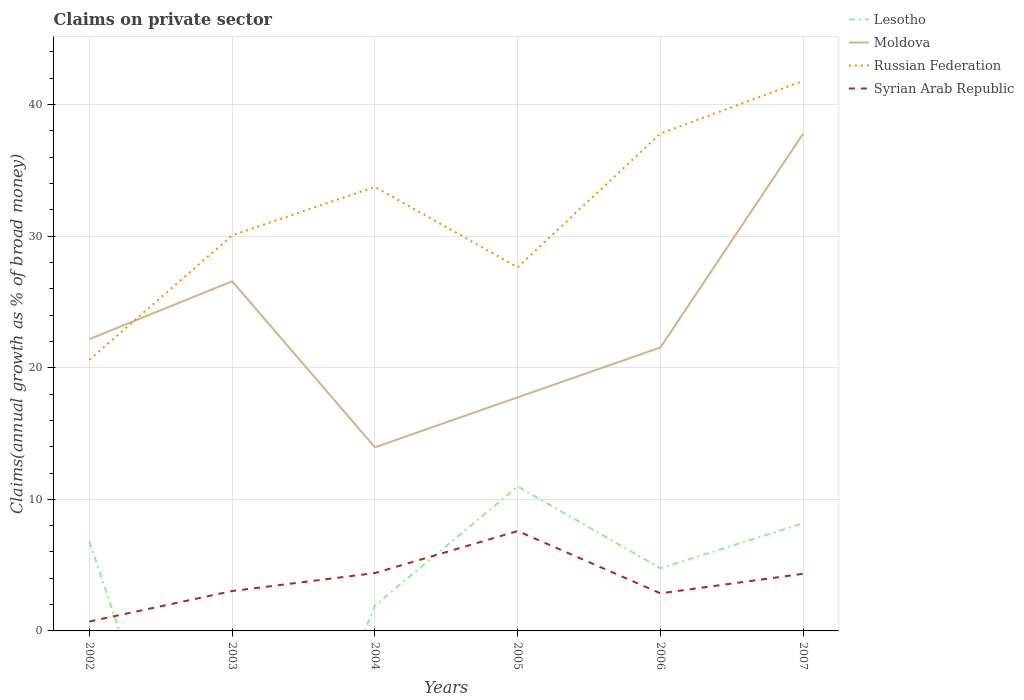How many different coloured lines are there?
Offer a terse response. 4. Across all years, what is the maximum percentage of broad money claimed on private sector in Moldova?
Make the answer very short. 13.96. What is the total percentage of broad money claimed on private sector in Russian Federation in the graph?
Offer a very short reply. -4. What is the difference between the highest and the second highest percentage of broad money claimed on private sector in Lesotho?
Your answer should be very brief. 10.98. Is the percentage of broad money claimed on private sector in Syrian Arab Republic strictly greater than the percentage of broad money claimed on private sector in Moldova over the years?
Your answer should be compact. Yes. How many lines are there?
Give a very brief answer. 4. How many years are there in the graph?
Your answer should be very brief. 6. What is the difference between two consecutive major ticks on the Y-axis?
Offer a terse response. 10. Are the values on the major ticks of Y-axis written in scientific E-notation?
Make the answer very short. No. Does the graph contain any zero values?
Make the answer very short. Yes. Does the graph contain grids?
Provide a short and direct response. Yes. Where does the legend appear in the graph?
Offer a very short reply. Top right. How many legend labels are there?
Your answer should be compact. 4. What is the title of the graph?
Keep it short and to the point. Claims on private sector. Does "Guam" appear as one of the legend labels in the graph?
Give a very brief answer. No. What is the label or title of the Y-axis?
Offer a terse response. Claims(annual growth as % of broad money). What is the Claims(annual growth as % of broad money) of Lesotho in 2002?
Your response must be concise. 6.79. What is the Claims(annual growth as % of broad money) of Moldova in 2002?
Give a very brief answer. 22.18. What is the Claims(annual growth as % of broad money) in Russian Federation in 2002?
Provide a short and direct response. 20.61. What is the Claims(annual growth as % of broad money) in Syrian Arab Republic in 2002?
Offer a very short reply. 0.72. What is the Claims(annual growth as % of broad money) of Moldova in 2003?
Your answer should be compact. 26.57. What is the Claims(annual growth as % of broad money) in Russian Federation in 2003?
Your answer should be very brief. 30.06. What is the Claims(annual growth as % of broad money) of Syrian Arab Republic in 2003?
Offer a terse response. 3.03. What is the Claims(annual growth as % of broad money) in Lesotho in 2004?
Offer a terse response. 1.94. What is the Claims(annual growth as % of broad money) in Moldova in 2004?
Your answer should be compact. 13.96. What is the Claims(annual growth as % of broad money) in Russian Federation in 2004?
Offer a terse response. 33.75. What is the Claims(annual growth as % of broad money) of Syrian Arab Republic in 2004?
Your response must be concise. 4.4. What is the Claims(annual growth as % of broad money) in Lesotho in 2005?
Make the answer very short. 10.98. What is the Claims(annual growth as % of broad money) in Moldova in 2005?
Offer a very short reply. 17.76. What is the Claims(annual growth as % of broad money) in Russian Federation in 2005?
Keep it short and to the point. 27.63. What is the Claims(annual growth as % of broad money) of Syrian Arab Republic in 2005?
Your answer should be compact. 7.59. What is the Claims(annual growth as % of broad money) in Lesotho in 2006?
Make the answer very short. 4.76. What is the Claims(annual growth as % of broad money) in Moldova in 2006?
Your answer should be compact. 21.54. What is the Claims(annual growth as % of broad money) in Russian Federation in 2006?
Provide a short and direct response. 37.8. What is the Claims(annual growth as % of broad money) of Syrian Arab Republic in 2006?
Ensure brevity in your answer.  2.86. What is the Claims(annual growth as % of broad money) in Lesotho in 2007?
Your answer should be compact. 8.18. What is the Claims(annual growth as % of broad money) in Moldova in 2007?
Your response must be concise. 37.79. What is the Claims(annual growth as % of broad money) in Russian Federation in 2007?
Keep it short and to the point. 41.8. What is the Claims(annual growth as % of broad money) in Syrian Arab Republic in 2007?
Your answer should be very brief. 4.34. Across all years, what is the maximum Claims(annual growth as % of broad money) of Lesotho?
Your response must be concise. 10.98. Across all years, what is the maximum Claims(annual growth as % of broad money) of Moldova?
Provide a succinct answer. 37.79. Across all years, what is the maximum Claims(annual growth as % of broad money) of Russian Federation?
Ensure brevity in your answer.  41.8. Across all years, what is the maximum Claims(annual growth as % of broad money) in Syrian Arab Republic?
Ensure brevity in your answer.  7.59. Across all years, what is the minimum Claims(annual growth as % of broad money) of Lesotho?
Your response must be concise. 0. Across all years, what is the minimum Claims(annual growth as % of broad money) in Moldova?
Ensure brevity in your answer.  13.96. Across all years, what is the minimum Claims(annual growth as % of broad money) in Russian Federation?
Ensure brevity in your answer.  20.61. Across all years, what is the minimum Claims(annual growth as % of broad money) in Syrian Arab Republic?
Offer a very short reply. 0.72. What is the total Claims(annual growth as % of broad money) of Lesotho in the graph?
Your answer should be compact. 32.65. What is the total Claims(annual growth as % of broad money) of Moldova in the graph?
Give a very brief answer. 139.79. What is the total Claims(annual growth as % of broad money) of Russian Federation in the graph?
Your response must be concise. 191.66. What is the total Claims(annual growth as % of broad money) in Syrian Arab Republic in the graph?
Ensure brevity in your answer.  22.94. What is the difference between the Claims(annual growth as % of broad money) of Moldova in 2002 and that in 2003?
Provide a succinct answer. -4.4. What is the difference between the Claims(annual growth as % of broad money) in Russian Federation in 2002 and that in 2003?
Your answer should be very brief. -9.45. What is the difference between the Claims(annual growth as % of broad money) in Syrian Arab Republic in 2002 and that in 2003?
Keep it short and to the point. -2.31. What is the difference between the Claims(annual growth as % of broad money) in Lesotho in 2002 and that in 2004?
Make the answer very short. 4.86. What is the difference between the Claims(annual growth as % of broad money) of Moldova in 2002 and that in 2004?
Offer a very short reply. 8.22. What is the difference between the Claims(annual growth as % of broad money) of Russian Federation in 2002 and that in 2004?
Your response must be concise. -13.14. What is the difference between the Claims(annual growth as % of broad money) in Syrian Arab Republic in 2002 and that in 2004?
Keep it short and to the point. -3.68. What is the difference between the Claims(annual growth as % of broad money) of Lesotho in 2002 and that in 2005?
Your response must be concise. -4.18. What is the difference between the Claims(annual growth as % of broad money) of Moldova in 2002 and that in 2005?
Your response must be concise. 4.42. What is the difference between the Claims(annual growth as % of broad money) of Russian Federation in 2002 and that in 2005?
Keep it short and to the point. -7.02. What is the difference between the Claims(annual growth as % of broad money) in Syrian Arab Republic in 2002 and that in 2005?
Give a very brief answer. -6.88. What is the difference between the Claims(annual growth as % of broad money) in Lesotho in 2002 and that in 2006?
Make the answer very short. 2.03. What is the difference between the Claims(annual growth as % of broad money) in Moldova in 2002 and that in 2006?
Give a very brief answer. 0.63. What is the difference between the Claims(annual growth as % of broad money) of Russian Federation in 2002 and that in 2006?
Offer a terse response. -17.19. What is the difference between the Claims(annual growth as % of broad money) in Syrian Arab Republic in 2002 and that in 2006?
Your answer should be very brief. -2.14. What is the difference between the Claims(annual growth as % of broad money) in Lesotho in 2002 and that in 2007?
Keep it short and to the point. -1.39. What is the difference between the Claims(annual growth as % of broad money) of Moldova in 2002 and that in 2007?
Give a very brief answer. -15.61. What is the difference between the Claims(annual growth as % of broad money) in Russian Federation in 2002 and that in 2007?
Ensure brevity in your answer.  -21.19. What is the difference between the Claims(annual growth as % of broad money) in Syrian Arab Republic in 2002 and that in 2007?
Ensure brevity in your answer.  -3.63. What is the difference between the Claims(annual growth as % of broad money) of Moldova in 2003 and that in 2004?
Your answer should be compact. 12.62. What is the difference between the Claims(annual growth as % of broad money) of Russian Federation in 2003 and that in 2004?
Offer a very short reply. -3.69. What is the difference between the Claims(annual growth as % of broad money) in Syrian Arab Republic in 2003 and that in 2004?
Your response must be concise. -1.37. What is the difference between the Claims(annual growth as % of broad money) of Moldova in 2003 and that in 2005?
Provide a short and direct response. 8.82. What is the difference between the Claims(annual growth as % of broad money) in Russian Federation in 2003 and that in 2005?
Your answer should be very brief. 2.43. What is the difference between the Claims(annual growth as % of broad money) in Syrian Arab Republic in 2003 and that in 2005?
Offer a terse response. -4.56. What is the difference between the Claims(annual growth as % of broad money) of Moldova in 2003 and that in 2006?
Your response must be concise. 5.03. What is the difference between the Claims(annual growth as % of broad money) of Russian Federation in 2003 and that in 2006?
Offer a terse response. -7.74. What is the difference between the Claims(annual growth as % of broad money) in Syrian Arab Republic in 2003 and that in 2006?
Your answer should be compact. 0.17. What is the difference between the Claims(annual growth as % of broad money) of Moldova in 2003 and that in 2007?
Keep it short and to the point. -11.22. What is the difference between the Claims(annual growth as % of broad money) in Russian Federation in 2003 and that in 2007?
Offer a very short reply. -11.74. What is the difference between the Claims(annual growth as % of broad money) of Syrian Arab Republic in 2003 and that in 2007?
Your response must be concise. -1.31. What is the difference between the Claims(annual growth as % of broad money) in Lesotho in 2004 and that in 2005?
Your answer should be compact. -9.04. What is the difference between the Claims(annual growth as % of broad money) in Moldova in 2004 and that in 2005?
Ensure brevity in your answer.  -3.8. What is the difference between the Claims(annual growth as % of broad money) of Russian Federation in 2004 and that in 2005?
Provide a succinct answer. 6.12. What is the difference between the Claims(annual growth as % of broad money) in Syrian Arab Republic in 2004 and that in 2005?
Your answer should be compact. -3.19. What is the difference between the Claims(annual growth as % of broad money) in Lesotho in 2004 and that in 2006?
Offer a very short reply. -2.82. What is the difference between the Claims(annual growth as % of broad money) of Moldova in 2004 and that in 2006?
Ensure brevity in your answer.  -7.59. What is the difference between the Claims(annual growth as % of broad money) of Russian Federation in 2004 and that in 2006?
Your answer should be very brief. -4.06. What is the difference between the Claims(annual growth as % of broad money) in Syrian Arab Republic in 2004 and that in 2006?
Your answer should be very brief. 1.54. What is the difference between the Claims(annual growth as % of broad money) of Lesotho in 2004 and that in 2007?
Your response must be concise. -6.24. What is the difference between the Claims(annual growth as % of broad money) of Moldova in 2004 and that in 2007?
Your answer should be very brief. -23.84. What is the difference between the Claims(annual growth as % of broad money) in Russian Federation in 2004 and that in 2007?
Provide a succinct answer. -8.06. What is the difference between the Claims(annual growth as % of broad money) of Syrian Arab Republic in 2004 and that in 2007?
Provide a short and direct response. 0.06. What is the difference between the Claims(annual growth as % of broad money) of Lesotho in 2005 and that in 2006?
Give a very brief answer. 6.22. What is the difference between the Claims(annual growth as % of broad money) in Moldova in 2005 and that in 2006?
Your answer should be very brief. -3.79. What is the difference between the Claims(annual growth as % of broad money) of Russian Federation in 2005 and that in 2006?
Give a very brief answer. -10.17. What is the difference between the Claims(annual growth as % of broad money) of Syrian Arab Republic in 2005 and that in 2006?
Your response must be concise. 4.74. What is the difference between the Claims(annual growth as % of broad money) of Lesotho in 2005 and that in 2007?
Make the answer very short. 2.8. What is the difference between the Claims(annual growth as % of broad money) in Moldova in 2005 and that in 2007?
Give a very brief answer. -20.04. What is the difference between the Claims(annual growth as % of broad money) of Russian Federation in 2005 and that in 2007?
Your answer should be compact. -14.17. What is the difference between the Claims(annual growth as % of broad money) in Syrian Arab Republic in 2005 and that in 2007?
Your response must be concise. 3.25. What is the difference between the Claims(annual growth as % of broad money) in Lesotho in 2006 and that in 2007?
Your answer should be compact. -3.42. What is the difference between the Claims(annual growth as % of broad money) of Moldova in 2006 and that in 2007?
Offer a terse response. -16.25. What is the difference between the Claims(annual growth as % of broad money) of Russian Federation in 2006 and that in 2007?
Offer a terse response. -4. What is the difference between the Claims(annual growth as % of broad money) of Syrian Arab Republic in 2006 and that in 2007?
Offer a very short reply. -1.48. What is the difference between the Claims(annual growth as % of broad money) in Lesotho in 2002 and the Claims(annual growth as % of broad money) in Moldova in 2003?
Your response must be concise. -19.78. What is the difference between the Claims(annual growth as % of broad money) in Lesotho in 2002 and the Claims(annual growth as % of broad money) in Russian Federation in 2003?
Give a very brief answer. -23.27. What is the difference between the Claims(annual growth as % of broad money) of Lesotho in 2002 and the Claims(annual growth as % of broad money) of Syrian Arab Republic in 2003?
Offer a very short reply. 3.76. What is the difference between the Claims(annual growth as % of broad money) in Moldova in 2002 and the Claims(annual growth as % of broad money) in Russian Federation in 2003?
Provide a short and direct response. -7.89. What is the difference between the Claims(annual growth as % of broad money) of Moldova in 2002 and the Claims(annual growth as % of broad money) of Syrian Arab Republic in 2003?
Your answer should be compact. 19.14. What is the difference between the Claims(annual growth as % of broad money) of Russian Federation in 2002 and the Claims(annual growth as % of broad money) of Syrian Arab Republic in 2003?
Offer a very short reply. 17.58. What is the difference between the Claims(annual growth as % of broad money) in Lesotho in 2002 and the Claims(annual growth as % of broad money) in Moldova in 2004?
Your answer should be very brief. -7.16. What is the difference between the Claims(annual growth as % of broad money) of Lesotho in 2002 and the Claims(annual growth as % of broad money) of Russian Federation in 2004?
Offer a very short reply. -26.96. What is the difference between the Claims(annual growth as % of broad money) of Lesotho in 2002 and the Claims(annual growth as % of broad money) of Syrian Arab Republic in 2004?
Provide a succinct answer. 2.39. What is the difference between the Claims(annual growth as % of broad money) of Moldova in 2002 and the Claims(annual growth as % of broad money) of Russian Federation in 2004?
Ensure brevity in your answer.  -11.57. What is the difference between the Claims(annual growth as % of broad money) of Moldova in 2002 and the Claims(annual growth as % of broad money) of Syrian Arab Republic in 2004?
Offer a terse response. 17.78. What is the difference between the Claims(annual growth as % of broad money) in Russian Federation in 2002 and the Claims(annual growth as % of broad money) in Syrian Arab Republic in 2004?
Offer a terse response. 16.21. What is the difference between the Claims(annual growth as % of broad money) in Lesotho in 2002 and the Claims(annual growth as % of broad money) in Moldova in 2005?
Ensure brevity in your answer.  -10.96. What is the difference between the Claims(annual growth as % of broad money) in Lesotho in 2002 and the Claims(annual growth as % of broad money) in Russian Federation in 2005?
Make the answer very short. -20.84. What is the difference between the Claims(annual growth as % of broad money) of Lesotho in 2002 and the Claims(annual growth as % of broad money) of Syrian Arab Republic in 2005?
Offer a terse response. -0.8. What is the difference between the Claims(annual growth as % of broad money) in Moldova in 2002 and the Claims(annual growth as % of broad money) in Russian Federation in 2005?
Your answer should be very brief. -5.46. What is the difference between the Claims(annual growth as % of broad money) in Moldova in 2002 and the Claims(annual growth as % of broad money) in Syrian Arab Republic in 2005?
Provide a short and direct response. 14.58. What is the difference between the Claims(annual growth as % of broad money) of Russian Federation in 2002 and the Claims(annual growth as % of broad money) of Syrian Arab Republic in 2005?
Keep it short and to the point. 13.02. What is the difference between the Claims(annual growth as % of broad money) of Lesotho in 2002 and the Claims(annual growth as % of broad money) of Moldova in 2006?
Offer a terse response. -14.75. What is the difference between the Claims(annual growth as % of broad money) of Lesotho in 2002 and the Claims(annual growth as % of broad money) of Russian Federation in 2006?
Give a very brief answer. -31.01. What is the difference between the Claims(annual growth as % of broad money) of Lesotho in 2002 and the Claims(annual growth as % of broad money) of Syrian Arab Republic in 2006?
Provide a short and direct response. 3.94. What is the difference between the Claims(annual growth as % of broad money) of Moldova in 2002 and the Claims(annual growth as % of broad money) of Russian Federation in 2006?
Offer a terse response. -15.63. What is the difference between the Claims(annual growth as % of broad money) of Moldova in 2002 and the Claims(annual growth as % of broad money) of Syrian Arab Republic in 2006?
Offer a terse response. 19.32. What is the difference between the Claims(annual growth as % of broad money) in Russian Federation in 2002 and the Claims(annual growth as % of broad money) in Syrian Arab Republic in 2006?
Ensure brevity in your answer.  17.75. What is the difference between the Claims(annual growth as % of broad money) in Lesotho in 2002 and the Claims(annual growth as % of broad money) in Moldova in 2007?
Ensure brevity in your answer.  -31. What is the difference between the Claims(annual growth as % of broad money) of Lesotho in 2002 and the Claims(annual growth as % of broad money) of Russian Federation in 2007?
Provide a short and direct response. -35.01. What is the difference between the Claims(annual growth as % of broad money) in Lesotho in 2002 and the Claims(annual growth as % of broad money) in Syrian Arab Republic in 2007?
Your response must be concise. 2.45. What is the difference between the Claims(annual growth as % of broad money) of Moldova in 2002 and the Claims(annual growth as % of broad money) of Russian Federation in 2007?
Offer a terse response. -19.63. What is the difference between the Claims(annual growth as % of broad money) in Moldova in 2002 and the Claims(annual growth as % of broad money) in Syrian Arab Republic in 2007?
Provide a short and direct response. 17.83. What is the difference between the Claims(annual growth as % of broad money) of Russian Federation in 2002 and the Claims(annual growth as % of broad money) of Syrian Arab Republic in 2007?
Your answer should be compact. 16.27. What is the difference between the Claims(annual growth as % of broad money) in Moldova in 2003 and the Claims(annual growth as % of broad money) in Russian Federation in 2004?
Make the answer very short. -7.18. What is the difference between the Claims(annual growth as % of broad money) of Moldova in 2003 and the Claims(annual growth as % of broad money) of Syrian Arab Republic in 2004?
Keep it short and to the point. 22.17. What is the difference between the Claims(annual growth as % of broad money) of Russian Federation in 2003 and the Claims(annual growth as % of broad money) of Syrian Arab Republic in 2004?
Provide a succinct answer. 25.66. What is the difference between the Claims(annual growth as % of broad money) in Moldova in 2003 and the Claims(annual growth as % of broad money) in Russian Federation in 2005?
Provide a short and direct response. -1.06. What is the difference between the Claims(annual growth as % of broad money) of Moldova in 2003 and the Claims(annual growth as % of broad money) of Syrian Arab Republic in 2005?
Keep it short and to the point. 18.98. What is the difference between the Claims(annual growth as % of broad money) in Russian Federation in 2003 and the Claims(annual growth as % of broad money) in Syrian Arab Republic in 2005?
Your response must be concise. 22.47. What is the difference between the Claims(annual growth as % of broad money) of Moldova in 2003 and the Claims(annual growth as % of broad money) of Russian Federation in 2006?
Give a very brief answer. -11.23. What is the difference between the Claims(annual growth as % of broad money) in Moldova in 2003 and the Claims(annual growth as % of broad money) in Syrian Arab Republic in 2006?
Make the answer very short. 23.72. What is the difference between the Claims(annual growth as % of broad money) of Russian Federation in 2003 and the Claims(annual growth as % of broad money) of Syrian Arab Republic in 2006?
Give a very brief answer. 27.21. What is the difference between the Claims(annual growth as % of broad money) of Moldova in 2003 and the Claims(annual growth as % of broad money) of Russian Federation in 2007?
Your response must be concise. -15.23. What is the difference between the Claims(annual growth as % of broad money) in Moldova in 2003 and the Claims(annual growth as % of broad money) in Syrian Arab Republic in 2007?
Offer a very short reply. 22.23. What is the difference between the Claims(annual growth as % of broad money) in Russian Federation in 2003 and the Claims(annual growth as % of broad money) in Syrian Arab Republic in 2007?
Provide a succinct answer. 25.72. What is the difference between the Claims(annual growth as % of broad money) in Lesotho in 2004 and the Claims(annual growth as % of broad money) in Moldova in 2005?
Give a very brief answer. -15.82. What is the difference between the Claims(annual growth as % of broad money) of Lesotho in 2004 and the Claims(annual growth as % of broad money) of Russian Federation in 2005?
Your response must be concise. -25.7. What is the difference between the Claims(annual growth as % of broad money) in Lesotho in 2004 and the Claims(annual growth as % of broad money) in Syrian Arab Republic in 2005?
Provide a succinct answer. -5.66. What is the difference between the Claims(annual growth as % of broad money) in Moldova in 2004 and the Claims(annual growth as % of broad money) in Russian Federation in 2005?
Offer a very short reply. -13.68. What is the difference between the Claims(annual growth as % of broad money) in Moldova in 2004 and the Claims(annual growth as % of broad money) in Syrian Arab Republic in 2005?
Give a very brief answer. 6.36. What is the difference between the Claims(annual growth as % of broad money) in Russian Federation in 2004 and the Claims(annual growth as % of broad money) in Syrian Arab Republic in 2005?
Your response must be concise. 26.16. What is the difference between the Claims(annual growth as % of broad money) of Lesotho in 2004 and the Claims(annual growth as % of broad money) of Moldova in 2006?
Ensure brevity in your answer.  -19.61. What is the difference between the Claims(annual growth as % of broad money) in Lesotho in 2004 and the Claims(annual growth as % of broad money) in Russian Federation in 2006?
Offer a very short reply. -35.87. What is the difference between the Claims(annual growth as % of broad money) of Lesotho in 2004 and the Claims(annual growth as % of broad money) of Syrian Arab Republic in 2006?
Give a very brief answer. -0.92. What is the difference between the Claims(annual growth as % of broad money) in Moldova in 2004 and the Claims(annual growth as % of broad money) in Russian Federation in 2006?
Ensure brevity in your answer.  -23.85. What is the difference between the Claims(annual growth as % of broad money) of Moldova in 2004 and the Claims(annual growth as % of broad money) of Syrian Arab Republic in 2006?
Ensure brevity in your answer.  11.1. What is the difference between the Claims(annual growth as % of broad money) in Russian Federation in 2004 and the Claims(annual growth as % of broad money) in Syrian Arab Republic in 2006?
Provide a succinct answer. 30.89. What is the difference between the Claims(annual growth as % of broad money) in Lesotho in 2004 and the Claims(annual growth as % of broad money) in Moldova in 2007?
Your response must be concise. -35.85. What is the difference between the Claims(annual growth as % of broad money) in Lesotho in 2004 and the Claims(annual growth as % of broad money) in Russian Federation in 2007?
Provide a succinct answer. -39.87. What is the difference between the Claims(annual growth as % of broad money) of Lesotho in 2004 and the Claims(annual growth as % of broad money) of Syrian Arab Republic in 2007?
Give a very brief answer. -2.4. What is the difference between the Claims(annual growth as % of broad money) in Moldova in 2004 and the Claims(annual growth as % of broad money) in Russian Federation in 2007?
Keep it short and to the point. -27.85. What is the difference between the Claims(annual growth as % of broad money) of Moldova in 2004 and the Claims(annual growth as % of broad money) of Syrian Arab Republic in 2007?
Give a very brief answer. 9.61. What is the difference between the Claims(annual growth as % of broad money) in Russian Federation in 2004 and the Claims(annual growth as % of broad money) in Syrian Arab Republic in 2007?
Offer a very short reply. 29.41. What is the difference between the Claims(annual growth as % of broad money) in Lesotho in 2005 and the Claims(annual growth as % of broad money) in Moldova in 2006?
Offer a terse response. -10.57. What is the difference between the Claims(annual growth as % of broad money) in Lesotho in 2005 and the Claims(annual growth as % of broad money) in Russian Federation in 2006?
Your response must be concise. -26.83. What is the difference between the Claims(annual growth as % of broad money) in Lesotho in 2005 and the Claims(annual growth as % of broad money) in Syrian Arab Republic in 2006?
Your answer should be compact. 8.12. What is the difference between the Claims(annual growth as % of broad money) in Moldova in 2005 and the Claims(annual growth as % of broad money) in Russian Federation in 2006?
Provide a succinct answer. -20.05. What is the difference between the Claims(annual growth as % of broad money) of Moldova in 2005 and the Claims(annual growth as % of broad money) of Syrian Arab Republic in 2006?
Offer a very short reply. 14.9. What is the difference between the Claims(annual growth as % of broad money) in Russian Federation in 2005 and the Claims(annual growth as % of broad money) in Syrian Arab Republic in 2006?
Give a very brief answer. 24.78. What is the difference between the Claims(annual growth as % of broad money) in Lesotho in 2005 and the Claims(annual growth as % of broad money) in Moldova in 2007?
Your answer should be very brief. -26.81. What is the difference between the Claims(annual growth as % of broad money) in Lesotho in 2005 and the Claims(annual growth as % of broad money) in Russian Federation in 2007?
Provide a succinct answer. -30.83. What is the difference between the Claims(annual growth as % of broad money) of Lesotho in 2005 and the Claims(annual growth as % of broad money) of Syrian Arab Republic in 2007?
Your answer should be compact. 6.63. What is the difference between the Claims(annual growth as % of broad money) in Moldova in 2005 and the Claims(annual growth as % of broad money) in Russian Federation in 2007?
Your answer should be very brief. -24.05. What is the difference between the Claims(annual growth as % of broad money) of Moldova in 2005 and the Claims(annual growth as % of broad money) of Syrian Arab Republic in 2007?
Offer a very short reply. 13.41. What is the difference between the Claims(annual growth as % of broad money) of Russian Federation in 2005 and the Claims(annual growth as % of broad money) of Syrian Arab Republic in 2007?
Make the answer very short. 23.29. What is the difference between the Claims(annual growth as % of broad money) of Lesotho in 2006 and the Claims(annual growth as % of broad money) of Moldova in 2007?
Provide a short and direct response. -33.03. What is the difference between the Claims(annual growth as % of broad money) of Lesotho in 2006 and the Claims(annual growth as % of broad money) of Russian Federation in 2007?
Ensure brevity in your answer.  -37.04. What is the difference between the Claims(annual growth as % of broad money) in Lesotho in 2006 and the Claims(annual growth as % of broad money) in Syrian Arab Republic in 2007?
Make the answer very short. 0.42. What is the difference between the Claims(annual growth as % of broad money) in Moldova in 2006 and the Claims(annual growth as % of broad money) in Russian Federation in 2007?
Make the answer very short. -20.26. What is the difference between the Claims(annual growth as % of broad money) in Moldova in 2006 and the Claims(annual growth as % of broad money) in Syrian Arab Republic in 2007?
Provide a short and direct response. 17.2. What is the difference between the Claims(annual growth as % of broad money) of Russian Federation in 2006 and the Claims(annual growth as % of broad money) of Syrian Arab Republic in 2007?
Offer a terse response. 33.46. What is the average Claims(annual growth as % of broad money) in Lesotho per year?
Make the answer very short. 5.44. What is the average Claims(annual growth as % of broad money) in Moldova per year?
Make the answer very short. 23.3. What is the average Claims(annual growth as % of broad money) in Russian Federation per year?
Provide a short and direct response. 31.94. What is the average Claims(annual growth as % of broad money) of Syrian Arab Republic per year?
Give a very brief answer. 3.82. In the year 2002, what is the difference between the Claims(annual growth as % of broad money) in Lesotho and Claims(annual growth as % of broad money) in Moldova?
Your answer should be compact. -15.38. In the year 2002, what is the difference between the Claims(annual growth as % of broad money) of Lesotho and Claims(annual growth as % of broad money) of Russian Federation?
Ensure brevity in your answer.  -13.82. In the year 2002, what is the difference between the Claims(annual growth as % of broad money) of Lesotho and Claims(annual growth as % of broad money) of Syrian Arab Republic?
Give a very brief answer. 6.08. In the year 2002, what is the difference between the Claims(annual growth as % of broad money) of Moldova and Claims(annual growth as % of broad money) of Russian Federation?
Ensure brevity in your answer.  1.57. In the year 2002, what is the difference between the Claims(annual growth as % of broad money) of Moldova and Claims(annual growth as % of broad money) of Syrian Arab Republic?
Keep it short and to the point. 21.46. In the year 2002, what is the difference between the Claims(annual growth as % of broad money) of Russian Federation and Claims(annual growth as % of broad money) of Syrian Arab Republic?
Keep it short and to the point. 19.89. In the year 2003, what is the difference between the Claims(annual growth as % of broad money) in Moldova and Claims(annual growth as % of broad money) in Russian Federation?
Your answer should be compact. -3.49. In the year 2003, what is the difference between the Claims(annual growth as % of broad money) in Moldova and Claims(annual growth as % of broad money) in Syrian Arab Republic?
Keep it short and to the point. 23.54. In the year 2003, what is the difference between the Claims(annual growth as % of broad money) of Russian Federation and Claims(annual growth as % of broad money) of Syrian Arab Republic?
Your answer should be very brief. 27.03. In the year 2004, what is the difference between the Claims(annual growth as % of broad money) of Lesotho and Claims(annual growth as % of broad money) of Moldova?
Make the answer very short. -12.02. In the year 2004, what is the difference between the Claims(annual growth as % of broad money) of Lesotho and Claims(annual growth as % of broad money) of Russian Federation?
Your response must be concise. -31.81. In the year 2004, what is the difference between the Claims(annual growth as % of broad money) in Lesotho and Claims(annual growth as % of broad money) in Syrian Arab Republic?
Keep it short and to the point. -2.46. In the year 2004, what is the difference between the Claims(annual growth as % of broad money) in Moldova and Claims(annual growth as % of broad money) in Russian Federation?
Provide a short and direct response. -19.79. In the year 2004, what is the difference between the Claims(annual growth as % of broad money) in Moldova and Claims(annual growth as % of broad money) in Syrian Arab Republic?
Provide a short and direct response. 9.56. In the year 2004, what is the difference between the Claims(annual growth as % of broad money) in Russian Federation and Claims(annual growth as % of broad money) in Syrian Arab Republic?
Your answer should be very brief. 29.35. In the year 2005, what is the difference between the Claims(annual growth as % of broad money) of Lesotho and Claims(annual growth as % of broad money) of Moldova?
Provide a succinct answer. -6.78. In the year 2005, what is the difference between the Claims(annual growth as % of broad money) of Lesotho and Claims(annual growth as % of broad money) of Russian Federation?
Provide a short and direct response. -16.66. In the year 2005, what is the difference between the Claims(annual growth as % of broad money) in Lesotho and Claims(annual growth as % of broad money) in Syrian Arab Republic?
Your answer should be very brief. 3.38. In the year 2005, what is the difference between the Claims(annual growth as % of broad money) of Moldova and Claims(annual growth as % of broad money) of Russian Federation?
Keep it short and to the point. -9.88. In the year 2005, what is the difference between the Claims(annual growth as % of broad money) of Moldova and Claims(annual growth as % of broad money) of Syrian Arab Republic?
Offer a very short reply. 10.16. In the year 2005, what is the difference between the Claims(annual growth as % of broad money) of Russian Federation and Claims(annual growth as % of broad money) of Syrian Arab Republic?
Give a very brief answer. 20.04. In the year 2006, what is the difference between the Claims(annual growth as % of broad money) of Lesotho and Claims(annual growth as % of broad money) of Moldova?
Keep it short and to the point. -16.78. In the year 2006, what is the difference between the Claims(annual growth as % of broad money) in Lesotho and Claims(annual growth as % of broad money) in Russian Federation?
Keep it short and to the point. -33.04. In the year 2006, what is the difference between the Claims(annual growth as % of broad money) in Lesotho and Claims(annual growth as % of broad money) in Syrian Arab Republic?
Provide a succinct answer. 1.9. In the year 2006, what is the difference between the Claims(annual growth as % of broad money) of Moldova and Claims(annual growth as % of broad money) of Russian Federation?
Your answer should be compact. -16.26. In the year 2006, what is the difference between the Claims(annual growth as % of broad money) of Moldova and Claims(annual growth as % of broad money) of Syrian Arab Republic?
Your answer should be very brief. 18.69. In the year 2006, what is the difference between the Claims(annual growth as % of broad money) of Russian Federation and Claims(annual growth as % of broad money) of Syrian Arab Republic?
Give a very brief answer. 34.95. In the year 2007, what is the difference between the Claims(annual growth as % of broad money) in Lesotho and Claims(annual growth as % of broad money) in Moldova?
Your answer should be very brief. -29.61. In the year 2007, what is the difference between the Claims(annual growth as % of broad money) in Lesotho and Claims(annual growth as % of broad money) in Russian Federation?
Provide a short and direct response. -33.62. In the year 2007, what is the difference between the Claims(annual growth as % of broad money) in Lesotho and Claims(annual growth as % of broad money) in Syrian Arab Republic?
Your answer should be compact. 3.84. In the year 2007, what is the difference between the Claims(annual growth as % of broad money) in Moldova and Claims(annual growth as % of broad money) in Russian Federation?
Your answer should be very brief. -4.01. In the year 2007, what is the difference between the Claims(annual growth as % of broad money) of Moldova and Claims(annual growth as % of broad money) of Syrian Arab Republic?
Your answer should be compact. 33.45. In the year 2007, what is the difference between the Claims(annual growth as % of broad money) in Russian Federation and Claims(annual growth as % of broad money) in Syrian Arab Republic?
Keep it short and to the point. 37.46. What is the ratio of the Claims(annual growth as % of broad money) in Moldova in 2002 to that in 2003?
Offer a terse response. 0.83. What is the ratio of the Claims(annual growth as % of broad money) in Russian Federation in 2002 to that in 2003?
Provide a succinct answer. 0.69. What is the ratio of the Claims(annual growth as % of broad money) in Syrian Arab Republic in 2002 to that in 2003?
Your answer should be very brief. 0.24. What is the ratio of the Claims(annual growth as % of broad money) of Lesotho in 2002 to that in 2004?
Give a very brief answer. 3.51. What is the ratio of the Claims(annual growth as % of broad money) of Moldova in 2002 to that in 2004?
Offer a very short reply. 1.59. What is the ratio of the Claims(annual growth as % of broad money) of Russian Federation in 2002 to that in 2004?
Keep it short and to the point. 0.61. What is the ratio of the Claims(annual growth as % of broad money) of Syrian Arab Republic in 2002 to that in 2004?
Ensure brevity in your answer.  0.16. What is the ratio of the Claims(annual growth as % of broad money) in Lesotho in 2002 to that in 2005?
Ensure brevity in your answer.  0.62. What is the ratio of the Claims(annual growth as % of broad money) in Moldova in 2002 to that in 2005?
Offer a terse response. 1.25. What is the ratio of the Claims(annual growth as % of broad money) of Russian Federation in 2002 to that in 2005?
Provide a short and direct response. 0.75. What is the ratio of the Claims(annual growth as % of broad money) in Syrian Arab Republic in 2002 to that in 2005?
Ensure brevity in your answer.  0.09. What is the ratio of the Claims(annual growth as % of broad money) in Lesotho in 2002 to that in 2006?
Your answer should be compact. 1.43. What is the ratio of the Claims(annual growth as % of broad money) in Moldova in 2002 to that in 2006?
Provide a succinct answer. 1.03. What is the ratio of the Claims(annual growth as % of broad money) in Russian Federation in 2002 to that in 2006?
Your response must be concise. 0.55. What is the ratio of the Claims(annual growth as % of broad money) of Syrian Arab Republic in 2002 to that in 2006?
Give a very brief answer. 0.25. What is the ratio of the Claims(annual growth as % of broad money) of Lesotho in 2002 to that in 2007?
Offer a terse response. 0.83. What is the ratio of the Claims(annual growth as % of broad money) of Moldova in 2002 to that in 2007?
Offer a terse response. 0.59. What is the ratio of the Claims(annual growth as % of broad money) of Russian Federation in 2002 to that in 2007?
Give a very brief answer. 0.49. What is the ratio of the Claims(annual growth as % of broad money) of Syrian Arab Republic in 2002 to that in 2007?
Give a very brief answer. 0.16. What is the ratio of the Claims(annual growth as % of broad money) of Moldova in 2003 to that in 2004?
Your response must be concise. 1.9. What is the ratio of the Claims(annual growth as % of broad money) in Russian Federation in 2003 to that in 2004?
Keep it short and to the point. 0.89. What is the ratio of the Claims(annual growth as % of broad money) of Syrian Arab Republic in 2003 to that in 2004?
Your response must be concise. 0.69. What is the ratio of the Claims(annual growth as % of broad money) in Moldova in 2003 to that in 2005?
Your response must be concise. 1.5. What is the ratio of the Claims(annual growth as % of broad money) in Russian Federation in 2003 to that in 2005?
Your answer should be compact. 1.09. What is the ratio of the Claims(annual growth as % of broad money) in Syrian Arab Republic in 2003 to that in 2005?
Keep it short and to the point. 0.4. What is the ratio of the Claims(annual growth as % of broad money) of Moldova in 2003 to that in 2006?
Offer a terse response. 1.23. What is the ratio of the Claims(annual growth as % of broad money) in Russian Federation in 2003 to that in 2006?
Provide a short and direct response. 0.8. What is the ratio of the Claims(annual growth as % of broad money) of Syrian Arab Republic in 2003 to that in 2006?
Offer a very short reply. 1.06. What is the ratio of the Claims(annual growth as % of broad money) of Moldova in 2003 to that in 2007?
Provide a succinct answer. 0.7. What is the ratio of the Claims(annual growth as % of broad money) of Russian Federation in 2003 to that in 2007?
Offer a very short reply. 0.72. What is the ratio of the Claims(annual growth as % of broad money) of Syrian Arab Republic in 2003 to that in 2007?
Make the answer very short. 0.7. What is the ratio of the Claims(annual growth as % of broad money) in Lesotho in 2004 to that in 2005?
Provide a short and direct response. 0.18. What is the ratio of the Claims(annual growth as % of broad money) in Moldova in 2004 to that in 2005?
Make the answer very short. 0.79. What is the ratio of the Claims(annual growth as % of broad money) in Russian Federation in 2004 to that in 2005?
Your response must be concise. 1.22. What is the ratio of the Claims(annual growth as % of broad money) of Syrian Arab Republic in 2004 to that in 2005?
Give a very brief answer. 0.58. What is the ratio of the Claims(annual growth as % of broad money) in Lesotho in 2004 to that in 2006?
Provide a short and direct response. 0.41. What is the ratio of the Claims(annual growth as % of broad money) in Moldova in 2004 to that in 2006?
Provide a short and direct response. 0.65. What is the ratio of the Claims(annual growth as % of broad money) in Russian Federation in 2004 to that in 2006?
Your response must be concise. 0.89. What is the ratio of the Claims(annual growth as % of broad money) in Syrian Arab Republic in 2004 to that in 2006?
Your answer should be compact. 1.54. What is the ratio of the Claims(annual growth as % of broad money) in Lesotho in 2004 to that in 2007?
Your answer should be compact. 0.24. What is the ratio of the Claims(annual growth as % of broad money) in Moldova in 2004 to that in 2007?
Ensure brevity in your answer.  0.37. What is the ratio of the Claims(annual growth as % of broad money) in Russian Federation in 2004 to that in 2007?
Make the answer very short. 0.81. What is the ratio of the Claims(annual growth as % of broad money) in Syrian Arab Republic in 2004 to that in 2007?
Provide a succinct answer. 1.01. What is the ratio of the Claims(annual growth as % of broad money) of Lesotho in 2005 to that in 2006?
Keep it short and to the point. 2.31. What is the ratio of the Claims(annual growth as % of broad money) of Moldova in 2005 to that in 2006?
Offer a terse response. 0.82. What is the ratio of the Claims(annual growth as % of broad money) of Russian Federation in 2005 to that in 2006?
Ensure brevity in your answer.  0.73. What is the ratio of the Claims(annual growth as % of broad money) in Syrian Arab Republic in 2005 to that in 2006?
Ensure brevity in your answer.  2.66. What is the ratio of the Claims(annual growth as % of broad money) of Lesotho in 2005 to that in 2007?
Offer a terse response. 1.34. What is the ratio of the Claims(annual growth as % of broad money) in Moldova in 2005 to that in 2007?
Your answer should be very brief. 0.47. What is the ratio of the Claims(annual growth as % of broad money) in Russian Federation in 2005 to that in 2007?
Make the answer very short. 0.66. What is the ratio of the Claims(annual growth as % of broad money) of Syrian Arab Republic in 2005 to that in 2007?
Your answer should be compact. 1.75. What is the ratio of the Claims(annual growth as % of broad money) of Lesotho in 2006 to that in 2007?
Keep it short and to the point. 0.58. What is the ratio of the Claims(annual growth as % of broad money) in Moldova in 2006 to that in 2007?
Ensure brevity in your answer.  0.57. What is the ratio of the Claims(annual growth as % of broad money) of Russian Federation in 2006 to that in 2007?
Make the answer very short. 0.9. What is the ratio of the Claims(annual growth as % of broad money) in Syrian Arab Republic in 2006 to that in 2007?
Ensure brevity in your answer.  0.66. What is the difference between the highest and the second highest Claims(annual growth as % of broad money) of Lesotho?
Your response must be concise. 2.8. What is the difference between the highest and the second highest Claims(annual growth as % of broad money) of Moldova?
Make the answer very short. 11.22. What is the difference between the highest and the second highest Claims(annual growth as % of broad money) in Russian Federation?
Offer a very short reply. 4. What is the difference between the highest and the second highest Claims(annual growth as % of broad money) of Syrian Arab Republic?
Ensure brevity in your answer.  3.19. What is the difference between the highest and the lowest Claims(annual growth as % of broad money) of Lesotho?
Offer a very short reply. 10.98. What is the difference between the highest and the lowest Claims(annual growth as % of broad money) of Moldova?
Your response must be concise. 23.84. What is the difference between the highest and the lowest Claims(annual growth as % of broad money) of Russian Federation?
Provide a short and direct response. 21.19. What is the difference between the highest and the lowest Claims(annual growth as % of broad money) in Syrian Arab Republic?
Keep it short and to the point. 6.88. 